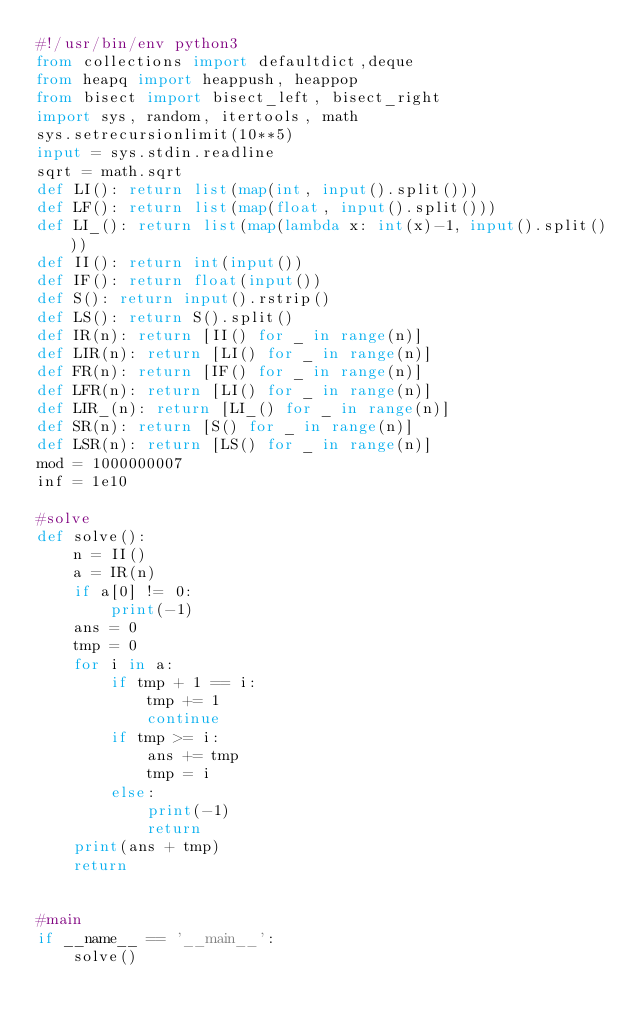<code> <loc_0><loc_0><loc_500><loc_500><_Python_>#!/usr/bin/env python3
from collections import defaultdict,deque
from heapq import heappush, heappop
from bisect import bisect_left, bisect_right
import sys, random, itertools, math
sys.setrecursionlimit(10**5)
input = sys.stdin.readline
sqrt = math.sqrt
def LI(): return list(map(int, input().split()))
def LF(): return list(map(float, input().split()))
def LI_(): return list(map(lambda x: int(x)-1, input().split()))
def II(): return int(input())
def IF(): return float(input())
def S(): return input().rstrip()
def LS(): return S().split()
def IR(n): return [II() for _ in range(n)]
def LIR(n): return [LI() for _ in range(n)]
def FR(n): return [IF() for _ in range(n)]
def LFR(n): return [LI() for _ in range(n)]
def LIR_(n): return [LI_() for _ in range(n)]
def SR(n): return [S() for _ in range(n)]
def LSR(n): return [LS() for _ in range(n)]
mod = 1000000007
inf = 1e10

#solve
def solve():
    n = II()
    a = IR(n)
    if a[0] != 0:
        print(-1)
    ans = 0
    tmp = 0
    for i in a:
        if tmp + 1 == i:
            tmp += 1
            continue
        if tmp >= i:
            ans += tmp
            tmp = i
        else:
            print(-1)
            return
    print(ans + tmp)
    return


#main
if __name__ == '__main__':
    solve()
</code> 